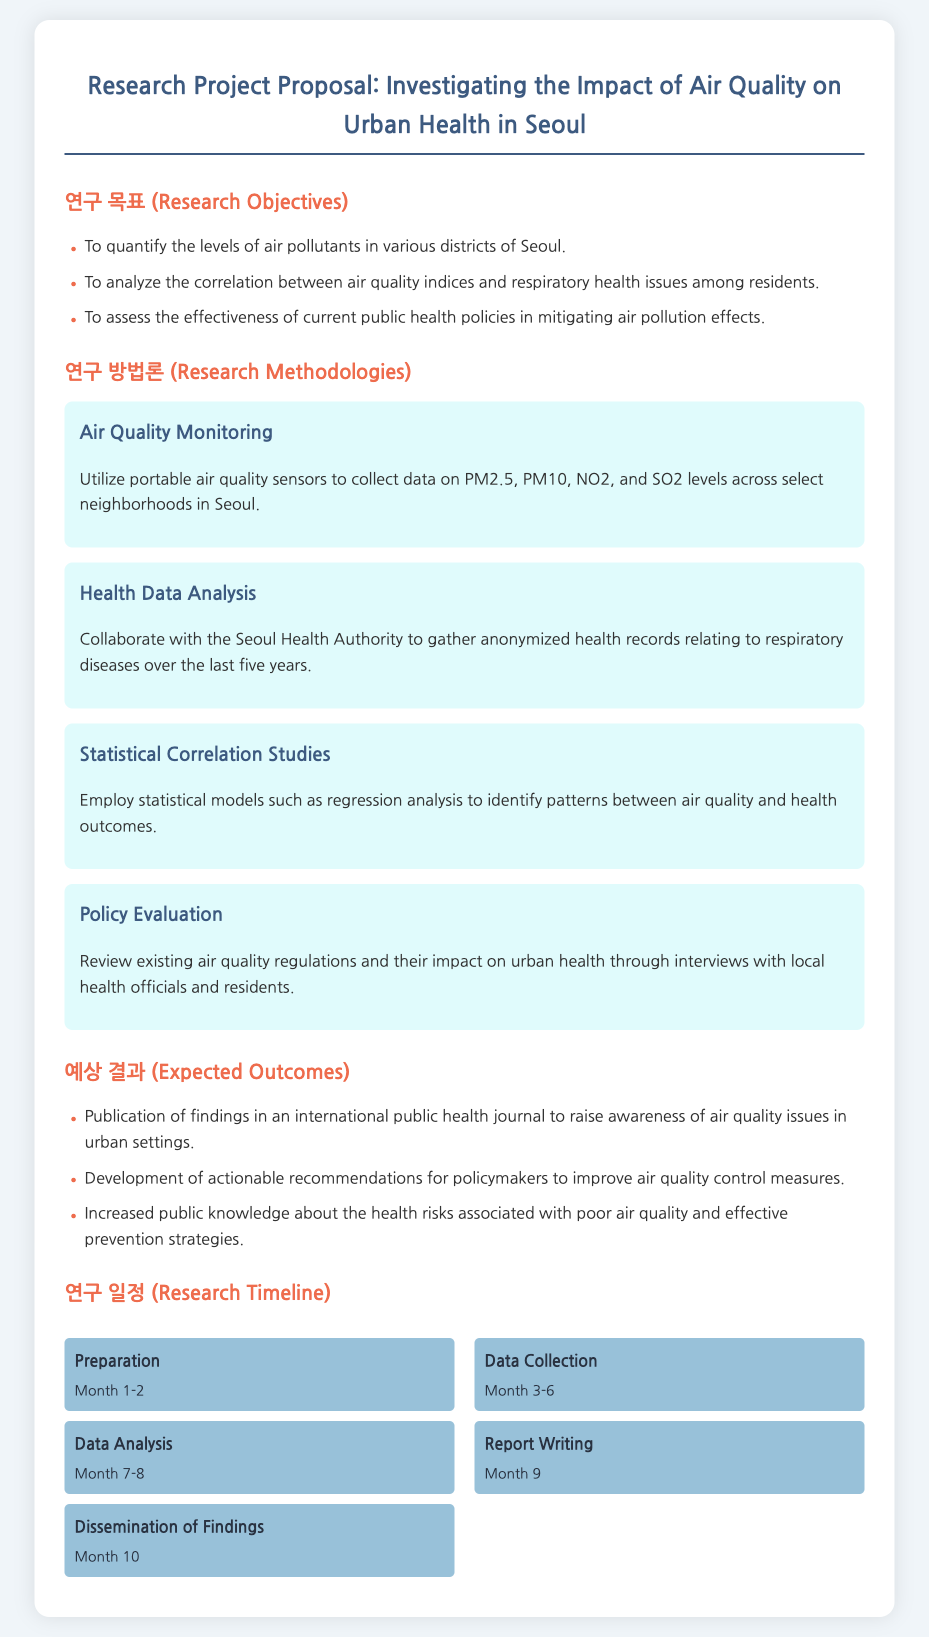What is the title of the research project proposal? The title of the research project proposal is specified at the top of the document.
Answer: Investigating the Impact of Air Quality on Urban Health in Seoul How many research objectives are listed? The document includes a specific list of research objectives.
Answer: Three What method is used for air quality monitoring? The section about air quality monitoring describes the specific method employed.
Answer: Portable air quality sensors What is the duration of the data collection phase? The timeline indicates the length of the data collection phase.
Answer: Month 3-6 Which pollutants are monitored in the study? The research methodologies section mentions the air pollutants being measured.
Answer: PM2.5, PM10, NO2, SO2 What is one expected outcome of the project? The expected outcomes section lists several anticipated results from the research.
Answer: Publication of findings in an international public health journal What statistical model will be used for analysis? The methodologies section specifies the type of statistical model to be employed.
Answer: Regression analysis What month is designated for report writing? The timeline outlines the specific month allocated for report writing.
Answer: Month 9 